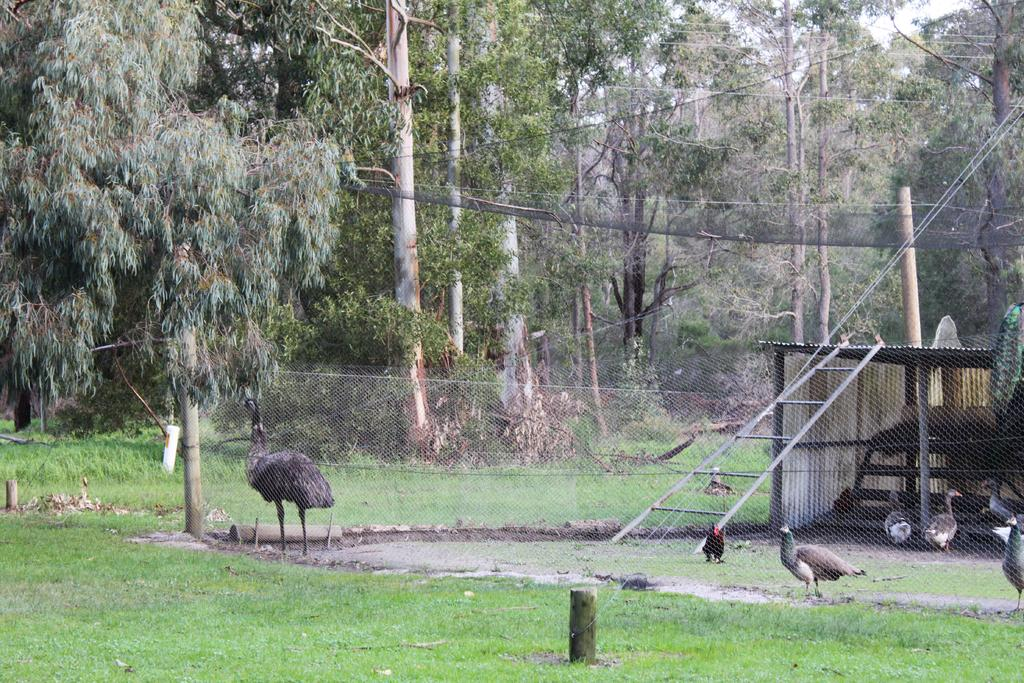What type of animals can be seen in the image? There are birds in the image. What structures are present in the image? There is a fence, poles, and a shed in the image. What type of vegetation is visible in the image? There are trees, plants, and grass in the image. What part of the natural environment is visible in the image? The sky is visible in the image. What type of protest is happening in the image? There is no protest present in the image. Can you tell me how many basketballs are visible in the image? There are no basketballs present in the image. 